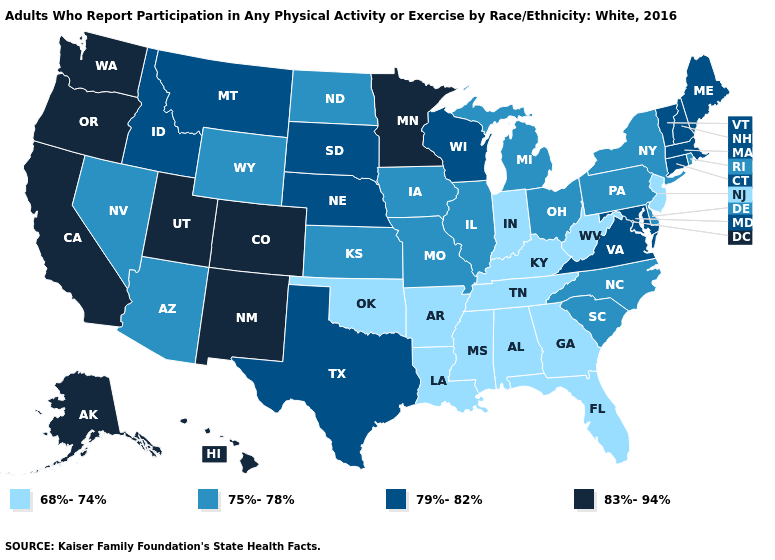Name the states that have a value in the range 83%-94%?
Be succinct. Alaska, California, Colorado, Hawaii, Minnesota, New Mexico, Oregon, Utah, Washington. Name the states that have a value in the range 68%-74%?
Be succinct. Alabama, Arkansas, Florida, Georgia, Indiana, Kentucky, Louisiana, Mississippi, New Jersey, Oklahoma, Tennessee, West Virginia. Among the states that border Wisconsin , does Minnesota have the highest value?
Quick response, please. Yes. How many symbols are there in the legend?
Quick response, please. 4. What is the highest value in the MidWest ?
Answer briefly. 83%-94%. Is the legend a continuous bar?
Answer briefly. No. Is the legend a continuous bar?
Short answer required. No. What is the value of Nevada?
Quick response, please. 75%-78%. What is the value of Delaware?
Be succinct. 75%-78%. What is the value of New Hampshire?
Write a very short answer. 79%-82%. What is the value of South Dakota?
Quick response, please. 79%-82%. What is the value of New Hampshire?
Keep it brief. 79%-82%. Does Arizona have the lowest value in the West?
Be succinct. Yes. What is the value of Mississippi?
Answer briefly. 68%-74%. Name the states that have a value in the range 68%-74%?
Write a very short answer. Alabama, Arkansas, Florida, Georgia, Indiana, Kentucky, Louisiana, Mississippi, New Jersey, Oklahoma, Tennessee, West Virginia. 